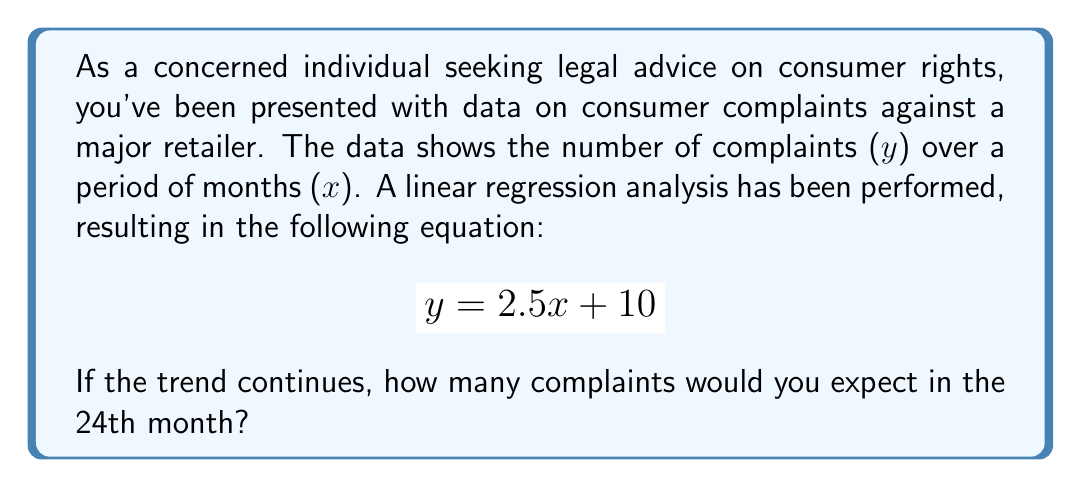Could you help me with this problem? To solve this problem, we'll follow these steps:

1. Understand the given equation:
   $$ y = 2.5x + 10 $$
   Where y is the number of complaints and x is the month number.

2. We need to find y when x = 24 (the 24th month).

3. Substitute x = 24 into the equation:
   $$ y = 2.5(24) + 10 $$

4. Calculate:
   $$ y = 60 + 10 $$
   $$ y = 70 $$

5. Therefore, if the trend continues, we would expect 70 complaints in the 24th month.

This linear regression analysis helps identify the trend in consumer complaints over time, which is crucial for understanding and addressing consumer rights issues.
Answer: 70 complaints 